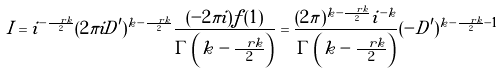<formula> <loc_0><loc_0><loc_500><loc_500>I = i ^ { - \frac { \ r k } { 2 } } ( 2 \pi i D ^ { \prime } ) ^ { k - \frac { \ r k } { 2 } } \frac { ( - 2 \pi i ) f ( 1 ) } { \Gamma \left ( k - \frac { \ r k } { 2 } \right ) } = \frac { ( 2 \pi ) ^ { k - \frac { \ r k } { 2 } } i ^ { - k } } { \Gamma \left ( k - \frac { \ r k } { 2 } \right ) } ( - D ^ { \prime } ) ^ { k - \frac { \ r k } { 2 } - 1 }</formula> 